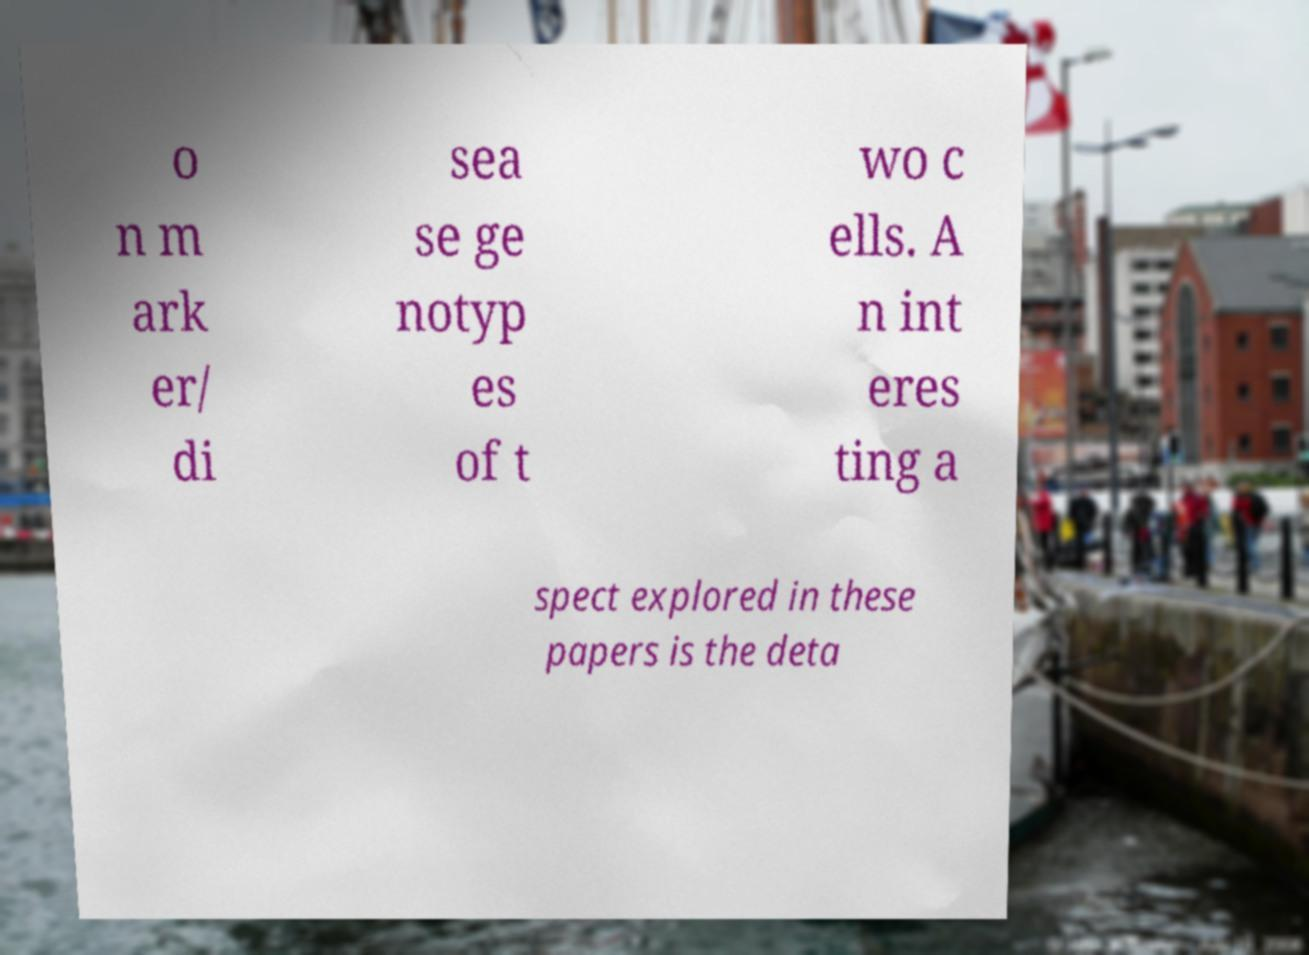There's text embedded in this image that I need extracted. Can you transcribe it verbatim? o n m ark er/ di sea se ge notyp es of t wo c ells. A n int eres ting a spect explored in these papers is the deta 